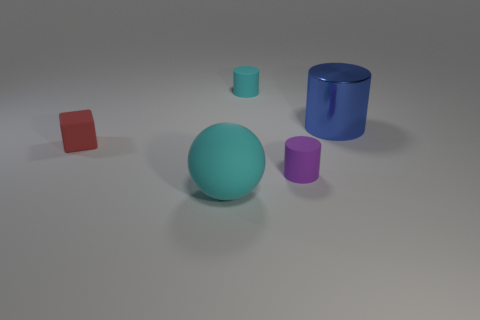Is there anything else that has the same material as the large blue object?
Keep it short and to the point. No. There is a tiny object that is the same color as the rubber sphere; what is its shape?
Provide a short and direct response. Cylinder. What size is the matte cylinder that is on the left side of the purple cylinder?
Keep it short and to the point. Small. What is the shape of the small red thing that is the same material as the small purple thing?
Ensure brevity in your answer.  Cube. Is the large sphere made of the same material as the cylinder behind the large metal cylinder?
Offer a very short reply. Yes. Does the cyan thing behind the purple thing have the same shape as the big metal object?
Ensure brevity in your answer.  Yes. There is a purple object that is the same shape as the large blue shiny object; what material is it?
Your response must be concise. Rubber. There is a purple matte thing; is it the same shape as the matte object that is in front of the small purple cylinder?
Offer a very short reply. No. What color is the matte object that is in front of the matte cube and behind the big cyan matte object?
Offer a very short reply. Purple. Is there a purple block?
Your answer should be very brief. No. 